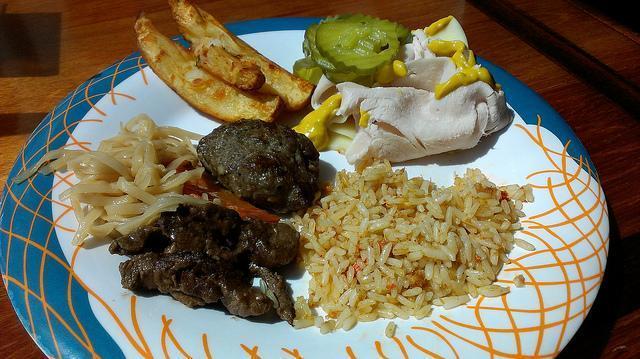How many people have their mouth open?
Give a very brief answer. 0. 